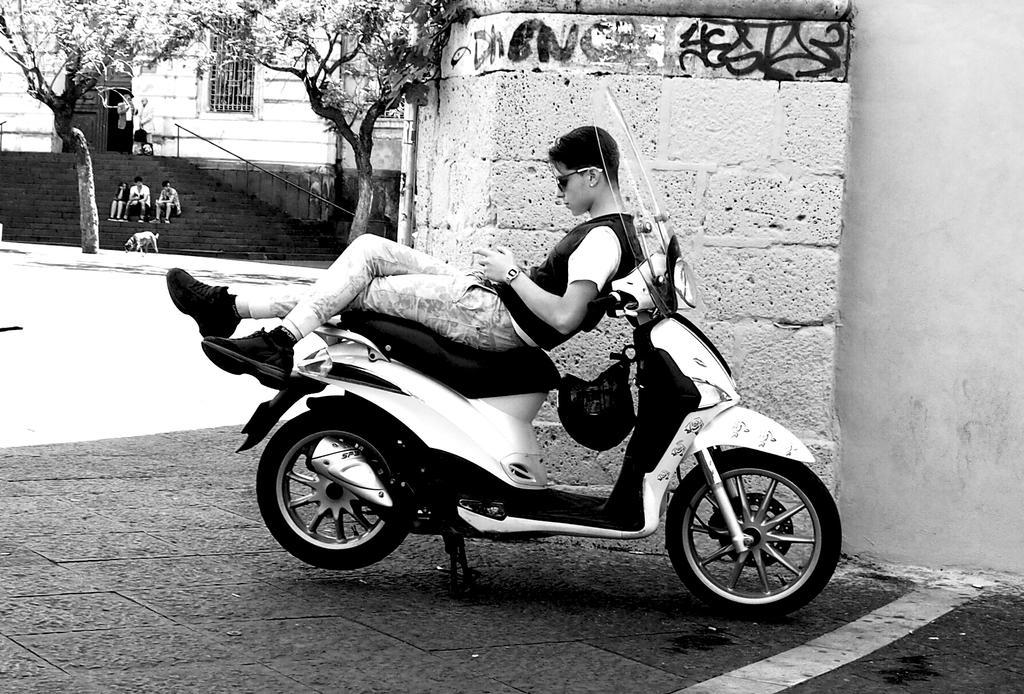Please provide a concise description of this image. this picture shows a man laid on the seat of a motorcycle and we see couple of trees and building and we see a dog and three people seated on the stairs 